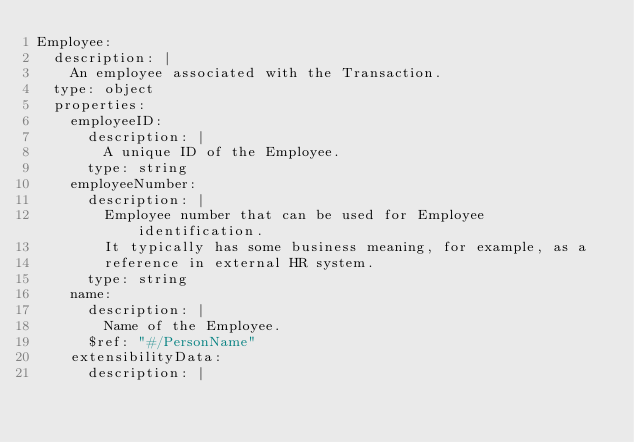Convert code to text. <code><loc_0><loc_0><loc_500><loc_500><_YAML_>Employee:
  description: |
    An employee associated with the Transaction.
  type: object
  properties:
    employeeID:
      description: |
        A unique ID of the Employee.
      type: string
    employeeNumber:
      description: |
        Employee number that can be used for Employee identification.
        It typically has some business meaning, for example, as a
        reference in external HR system.
      type: string
    name:
      description: |
        Name of the Employee.
      $ref: "#/PersonName"
    extensibilityData:
      description: |</code> 